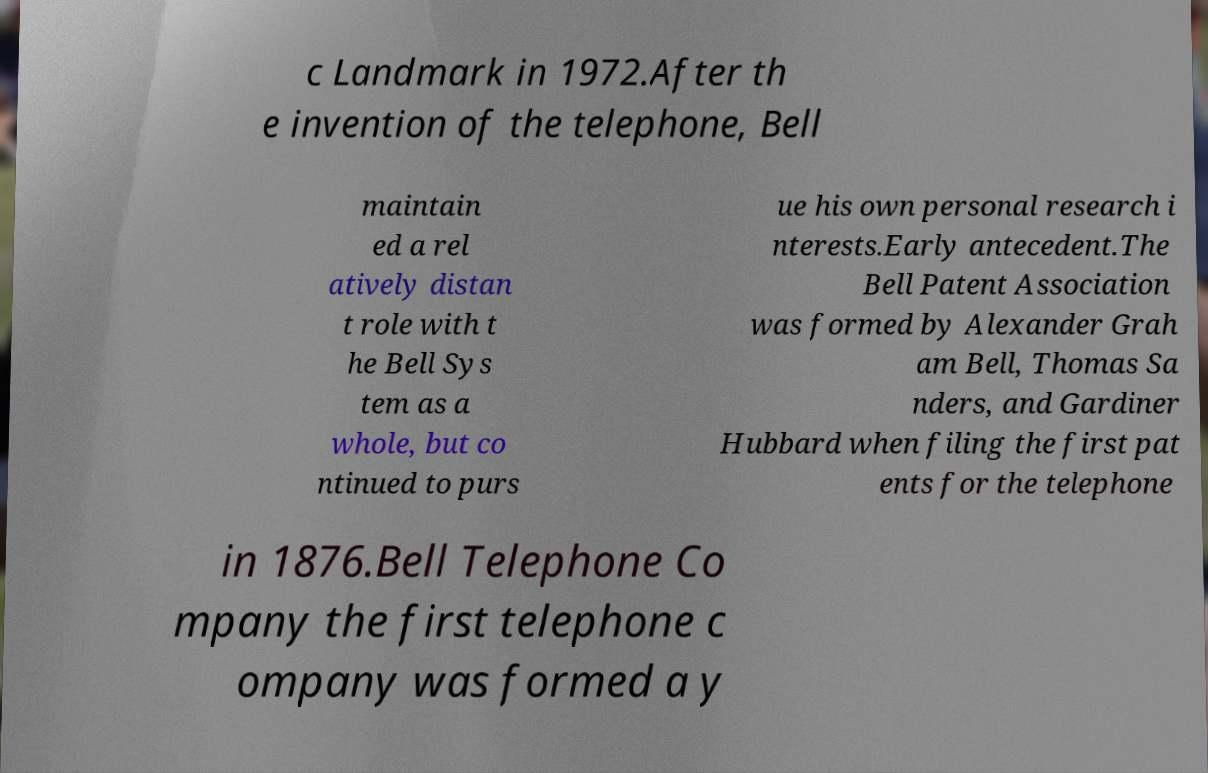There's text embedded in this image that I need extracted. Can you transcribe it verbatim? c Landmark in 1972.After th e invention of the telephone, Bell maintain ed a rel atively distan t role with t he Bell Sys tem as a whole, but co ntinued to purs ue his own personal research i nterests.Early antecedent.The Bell Patent Association was formed by Alexander Grah am Bell, Thomas Sa nders, and Gardiner Hubbard when filing the first pat ents for the telephone in 1876.Bell Telephone Co mpany the first telephone c ompany was formed a y 